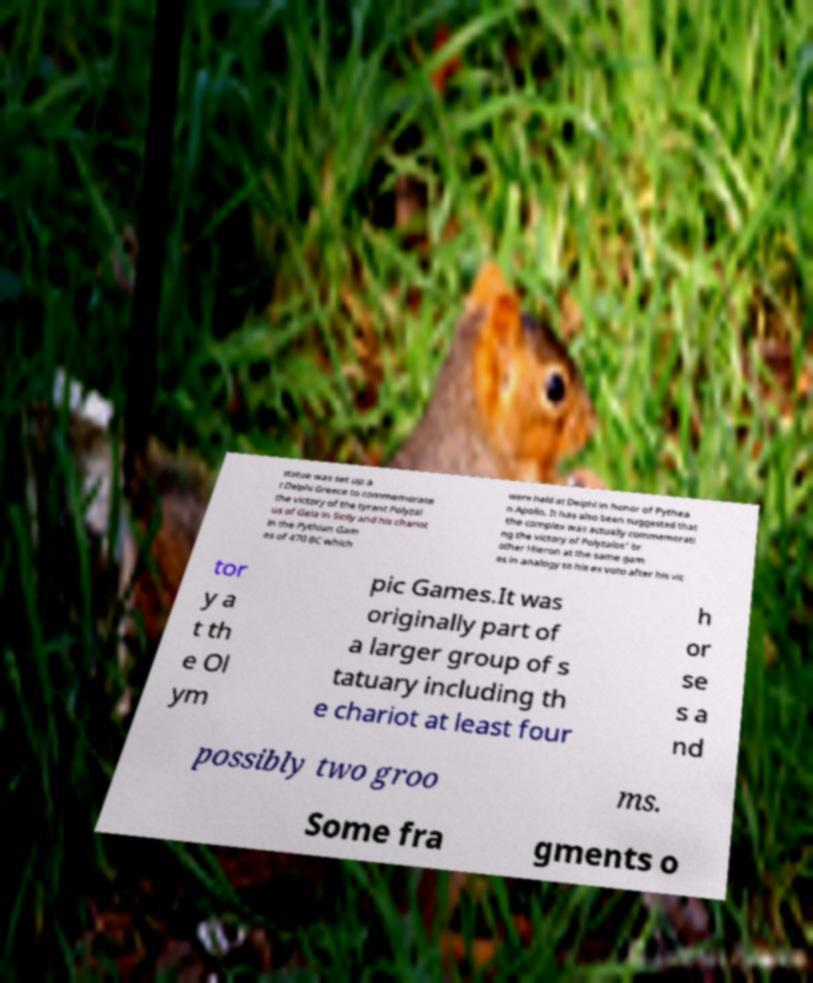Please read and relay the text visible in this image. What does it say? statue was set up a t Delphi Greece to commemorate the victory of the tyrant Polyzal us of Gela in Sicily and his chariot in the Pythian Gam es of 470 BC which were held at Delphi in honor of Pythea n Apollo. It has also been suggested that the complex was actually commemorati ng the victory of Polyzalos' br other Hieron at the same gam es in analogy to his ex voto after his vic tor y a t th e Ol ym pic Games.It was originally part of a larger group of s tatuary including th e chariot at least four h or se s a nd possibly two groo ms. Some fra gments o 